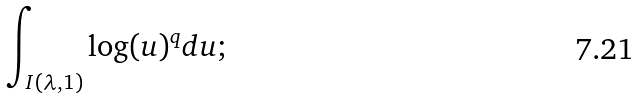<formula> <loc_0><loc_0><loc_500><loc_500>\int _ { I ( \lambda , 1 ) } \log ( u ) ^ { q } d u ;</formula> 